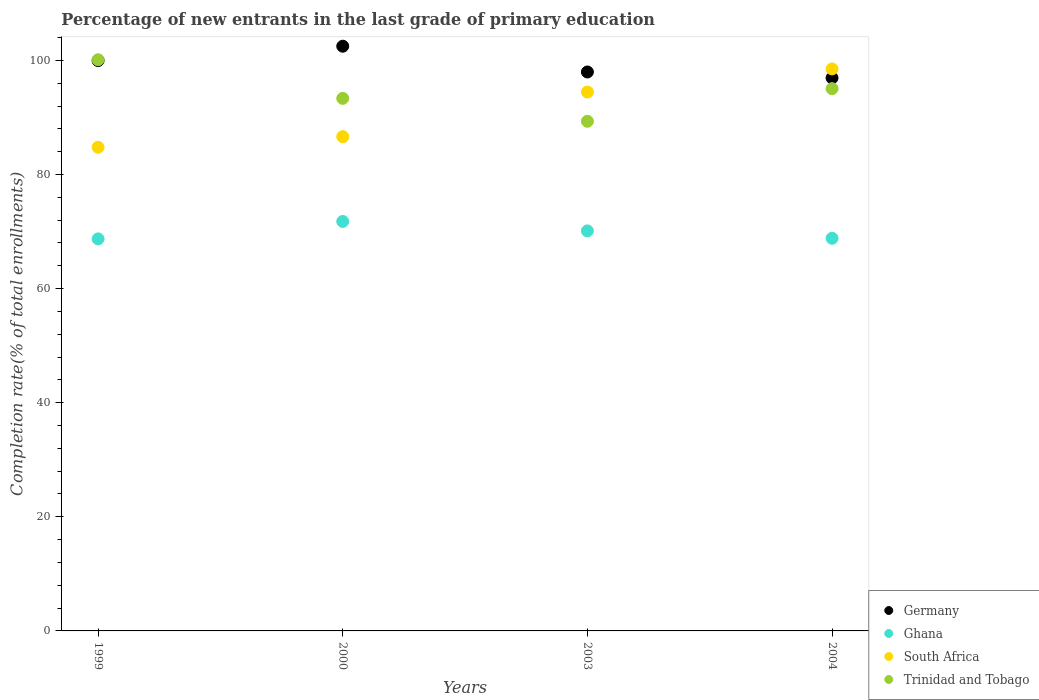How many different coloured dotlines are there?
Offer a very short reply. 4. What is the percentage of new entrants in Trinidad and Tobago in 2004?
Give a very brief answer. 95.05. Across all years, what is the maximum percentage of new entrants in Germany?
Provide a succinct answer. 102.49. Across all years, what is the minimum percentage of new entrants in Trinidad and Tobago?
Your answer should be very brief. 89.33. In which year was the percentage of new entrants in Trinidad and Tobago maximum?
Provide a succinct answer. 1999. What is the total percentage of new entrants in South Africa in the graph?
Your response must be concise. 364.36. What is the difference between the percentage of new entrants in Trinidad and Tobago in 2000 and that in 2004?
Keep it short and to the point. -1.7. What is the difference between the percentage of new entrants in Ghana in 1999 and the percentage of new entrants in South Africa in 2000?
Keep it short and to the point. -17.91. What is the average percentage of new entrants in Ghana per year?
Offer a terse response. 69.86. In the year 2000, what is the difference between the percentage of new entrants in Ghana and percentage of new entrants in Trinidad and Tobago?
Provide a succinct answer. -21.57. In how many years, is the percentage of new entrants in Trinidad and Tobago greater than 100 %?
Keep it short and to the point. 1. What is the ratio of the percentage of new entrants in Ghana in 1999 to that in 2000?
Provide a succinct answer. 0.96. Is the percentage of new entrants in South Africa in 2003 less than that in 2004?
Offer a very short reply. Yes. Is the difference between the percentage of new entrants in Ghana in 2000 and 2004 greater than the difference between the percentage of new entrants in Trinidad and Tobago in 2000 and 2004?
Make the answer very short. Yes. What is the difference between the highest and the second highest percentage of new entrants in Trinidad and Tobago?
Your answer should be compact. 5.07. What is the difference between the highest and the lowest percentage of new entrants in Trinidad and Tobago?
Keep it short and to the point. 10.78. Is the sum of the percentage of new entrants in Germany in 1999 and 2004 greater than the maximum percentage of new entrants in Trinidad and Tobago across all years?
Keep it short and to the point. Yes. Is it the case that in every year, the sum of the percentage of new entrants in Trinidad and Tobago and percentage of new entrants in Germany  is greater than the sum of percentage of new entrants in Ghana and percentage of new entrants in South Africa?
Your answer should be very brief. No. Does the percentage of new entrants in South Africa monotonically increase over the years?
Your response must be concise. Yes. Does the graph contain grids?
Keep it short and to the point. No. How many legend labels are there?
Keep it short and to the point. 4. What is the title of the graph?
Provide a short and direct response. Percentage of new entrants in the last grade of primary education. Does "Gambia, The" appear as one of the legend labels in the graph?
Offer a terse response. No. What is the label or title of the X-axis?
Provide a short and direct response. Years. What is the label or title of the Y-axis?
Your answer should be very brief. Completion rate(% of total enrollments). What is the Completion rate(% of total enrollments) in Germany in 1999?
Provide a succinct answer. 99.97. What is the Completion rate(% of total enrollments) of Ghana in 1999?
Offer a very short reply. 68.71. What is the Completion rate(% of total enrollments) of South Africa in 1999?
Offer a very short reply. 84.77. What is the Completion rate(% of total enrollments) of Trinidad and Tobago in 1999?
Provide a succinct answer. 100.11. What is the Completion rate(% of total enrollments) in Germany in 2000?
Ensure brevity in your answer.  102.49. What is the Completion rate(% of total enrollments) of Ghana in 2000?
Keep it short and to the point. 71.77. What is the Completion rate(% of total enrollments) in South Africa in 2000?
Make the answer very short. 86.62. What is the Completion rate(% of total enrollments) in Trinidad and Tobago in 2000?
Give a very brief answer. 93.35. What is the Completion rate(% of total enrollments) of Germany in 2003?
Offer a terse response. 97.97. What is the Completion rate(% of total enrollments) in Ghana in 2003?
Provide a succinct answer. 70.12. What is the Completion rate(% of total enrollments) in South Africa in 2003?
Your response must be concise. 94.45. What is the Completion rate(% of total enrollments) in Trinidad and Tobago in 2003?
Offer a terse response. 89.33. What is the Completion rate(% of total enrollments) of Germany in 2004?
Offer a terse response. 96.93. What is the Completion rate(% of total enrollments) of Ghana in 2004?
Offer a terse response. 68.82. What is the Completion rate(% of total enrollments) of South Africa in 2004?
Keep it short and to the point. 98.51. What is the Completion rate(% of total enrollments) of Trinidad and Tobago in 2004?
Offer a very short reply. 95.05. Across all years, what is the maximum Completion rate(% of total enrollments) of Germany?
Your answer should be very brief. 102.49. Across all years, what is the maximum Completion rate(% of total enrollments) of Ghana?
Give a very brief answer. 71.77. Across all years, what is the maximum Completion rate(% of total enrollments) in South Africa?
Keep it short and to the point. 98.51. Across all years, what is the maximum Completion rate(% of total enrollments) in Trinidad and Tobago?
Ensure brevity in your answer.  100.11. Across all years, what is the minimum Completion rate(% of total enrollments) in Germany?
Your answer should be very brief. 96.93. Across all years, what is the minimum Completion rate(% of total enrollments) in Ghana?
Your answer should be very brief. 68.71. Across all years, what is the minimum Completion rate(% of total enrollments) of South Africa?
Offer a very short reply. 84.77. Across all years, what is the minimum Completion rate(% of total enrollments) in Trinidad and Tobago?
Your answer should be very brief. 89.33. What is the total Completion rate(% of total enrollments) of Germany in the graph?
Offer a very short reply. 397.36. What is the total Completion rate(% of total enrollments) of Ghana in the graph?
Your response must be concise. 279.42. What is the total Completion rate(% of total enrollments) of South Africa in the graph?
Offer a very short reply. 364.36. What is the total Completion rate(% of total enrollments) of Trinidad and Tobago in the graph?
Offer a terse response. 377.84. What is the difference between the Completion rate(% of total enrollments) in Germany in 1999 and that in 2000?
Ensure brevity in your answer.  -2.52. What is the difference between the Completion rate(% of total enrollments) in Ghana in 1999 and that in 2000?
Your response must be concise. -3.06. What is the difference between the Completion rate(% of total enrollments) in South Africa in 1999 and that in 2000?
Provide a short and direct response. -1.85. What is the difference between the Completion rate(% of total enrollments) of Trinidad and Tobago in 1999 and that in 2000?
Your answer should be compact. 6.77. What is the difference between the Completion rate(% of total enrollments) in Germany in 1999 and that in 2003?
Provide a succinct answer. 1.99. What is the difference between the Completion rate(% of total enrollments) of Ghana in 1999 and that in 2003?
Offer a terse response. -1.4. What is the difference between the Completion rate(% of total enrollments) of South Africa in 1999 and that in 2003?
Ensure brevity in your answer.  -9.68. What is the difference between the Completion rate(% of total enrollments) of Trinidad and Tobago in 1999 and that in 2003?
Provide a succinct answer. 10.78. What is the difference between the Completion rate(% of total enrollments) in Germany in 1999 and that in 2004?
Give a very brief answer. 3.04. What is the difference between the Completion rate(% of total enrollments) in Ghana in 1999 and that in 2004?
Provide a short and direct response. -0.11. What is the difference between the Completion rate(% of total enrollments) in South Africa in 1999 and that in 2004?
Give a very brief answer. -13.73. What is the difference between the Completion rate(% of total enrollments) in Trinidad and Tobago in 1999 and that in 2004?
Ensure brevity in your answer.  5.07. What is the difference between the Completion rate(% of total enrollments) in Germany in 2000 and that in 2003?
Ensure brevity in your answer.  4.52. What is the difference between the Completion rate(% of total enrollments) of Ghana in 2000 and that in 2003?
Your answer should be compact. 1.66. What is the difference between the Completion rate(% of total enrollments) of South Africa in 2000 and that in 2003?
Offer a very short reply. -7.83. What is the difference between the Completion rate(% of total enrollments) in Trinidad and Tobago in 2000 and that in 2003?
Provide a short and direct response. 4.02. What is the difference between the Completion rate(% of total enrollments) in Germany in 2000 and that in 2004?
Ensure brevity in your answer.  5.56. What is the difference between the Completion rate(% of total enrollments) of Ghana in 2000 and that in 2004?
Your answer should be compact. 2.95. What is the difference between the Completion rate(% of total enrollments) in South Africa in 2000 and that in 2004?
Provide a short and direct response. -11.88. What is the difference between the Completion rate(% of total enrollments) of Trinidad and Tobago in 2000 and that in 2004?
Ensure brevity in your answer.  -1.7. What is the difference between the Completion rate(% of total enrollments) of Germany in 2003 and that in 2004?
Provide a succinct answer. 1.04. What is the difference between the Completion rate(% of total enrollments) in Ghana in 2003 and that in 2004?
Offer a terse response. 1.3. What is the difference between the Completion rate(% of total enrollments) of South Africa in 2003 and that in 2004?
Provide a succinct answer. -4.06. What is the difference between the Completion rate(% of total enrollments) of Trinidad and Tobago in 2003 and that in 2004?
Offer a terse response. -5.71. What is the difference between the Completion rate(% of total enrollments) in Germany in 1999 and the Completion rate(% of total enrollments) in Ghana in 2000?
Ensure brevity in your answer.  28.19. What is the difference between the Completion rate(% of total enrollments) in Germany in 1999 and the Completion rate(% of total enrollments) in South Africa in 2000?
Offer a very short reply. 13.34. What is the difference between the Completion rate(% of total enrollments) in Germany in 1999 and the Completion rate(% of total enrollments) in Trinidad and Tobago in 2000?
Give a very brief answer. 6.62. What is the difference between the Completion rate(% of total enrollments) of Ghana in 1999 and the Completion rate(% of total enrollments) of South Africa in 2000?
Keep it short and to the point. -17.91. What is the difference between the Completion rate(% of total enrollments) of Ghana in 1999 and the Completion rate(% of total enrollments) of Trinidad and Tobago in 2000?
Your response must be concise. -24.63. What is the difference between the Completion rate(% of total enrollments) of South Africa in 1999 and the Completion rate(% of total enrollments) of Trinidad and Tobago in 2000?
Provide a succinct answer. -8.57. What is the difference between the Completion rate(% of total enrollments) in Germany in 1999 and the Completion rate(% of total enrollments) in Ghana in 2003?
Offer a very short reply. 29.85. What is the difference between the Completion rate(% of total enrollments) of Germany in 1999 and the Completion rate(% of total enrollments) of South Africa in 2003?
Give a very brief answer. 5.52. What is the difference between the Completion rate(% of total enrollments) in Germany in 1999 and the Completion rate(% of total enrollments) in Trinidad and Tobago in 2003?
Ensure brevity in your answer.  10.63. What is the difference between the Completion rate(% of total enrollments) of Ghana in 1999 and the Completion rate(% of total enrollments) of South Africa in 2003?
Your answer should be very brief. -25.74. What is the difference between the Completion rate(% of total enrollments) in Ghana in 1999 and the Completion rate(% of total enrollments) in Trinidad and Tobago in 2003?
Give a very brief answer. -20.62. What is the difference between the Completion rate(% of total enrollments) in South Africa in 1999 and the Completion rate(% of total enrollments) in Trinidad and Tobago in 2003?
Ensure brevity in your answer.  -4.56. What is the difference between the Completion rate(% of total enrollments) in Germany in 1999 and the Completion rate(% of total enrollments) in Ghana in 2004?
Offer a terse response. 31.15. What is the difference between the Completion rate(% of total enrollments) of Germany in 1999 and the Completion rate(% of total enrollments) of South Africa in 2004?
Make the answer very short. 1.46. What is the difference between the Completion rate(% of total enrollments) of Germany in 1999 and the Completion rate(% of total enrollments) of Trinidad and Tobago in 2004?
Give a very brief answer. 4.92. What is the difference between the Completion rate(% of total enrollments) in Ghana in 1999 and the Completion rate(% of total enrollments) in South Africa in 2004?
Provide a succinct answer. -29.79. What is the difference between the Completion rate(% of total enrollments) of Ghana in 1999 and the Completion rate(% of total enrollments) of Trinidad and Tobago in 2004?
Make the answer very short. -26.33. What is the difference between the Completion rate(% of total enrollments) of South Africa in 1999 and the Completion rate(% of total enrollments) of Trinidad and Tobago in 2004?
Your answer should be very brief. -10.27. What is the difference between the Completion rate(% of total enrollments) of Germany in 2000 and the Completion rate(% of total enrollments) of Ghana in 2003?
Your answer should be compact. 32.37. What is the difference between the Completion rate(% of total enrollments) of Germany in 2000 and the Completion rate(% of total enrollments) of South Africa in 2003?
Keep it short and to the point. 8.04. What is the difference between the Completion rate(% of total enrollments) of Germany in 2000 and the Completion rate(% of total enrollments) of Trinidad and Tobago in 2003?
Give a very brief answer. 13.16. What is the difference between the Completion rate(% of total enrollments) of Ghana in 2000 and the Completion rate(% of total enrollments) of South Africa in 2003?
Keep it short and to the point. -22.68. What is the difference between the Completion rate(% of total enrollments) in Ghana in 2000 and the Completion rate(% of total enrollments) in Trinidad and Tobago in 2003?
Your response must be concise. -17.56. What is the difference between the Completion rate(% of total enrollments) in South Africa in 2000 and the Completion rate(% of total enrollments) in Trinidad and Tobago in 2003?
Your answer should be very brief. -2.71. What is the difference between the Completion rate(% of total enrollments) in Germany in 2000 and the Completion rate(% of total enrollments) in Ghana in 2004?
Your answer should be compact. 33.67. What is the difference between the Completion rate(% of total enrollments) of Germany in 2000 and the Completion rate(% of total enrollments) of South Africa in 2004?
Provide a succinct answer. 3.98. What is the difference between the Completion rate(% of total enrollments) in Germany in 2000 and the Completion rate(% of total enrollments) in Trinidad and Tobago in 2004?
Keep it short and to the point. 7.44. What is the difference between the Completion rate(% of total enrollments) in Ghana in 2000 and the Completion rate(% of total enrollments) in South Africa in 2004?
Your answer should be compact. -26.73. What is the difference between the Completion rate(% of total enrollments) of Ghana in 2000 and the Completion rate(% of total enrollments) of Trinidad and Tobago in 2004?
Provide a short and direct response. -23.27. What is the difference between the Completion rate(% of total enrollments) of South Africa in 2000 and the Completion rate(% of total enrollments) of Trinidad and Tobago in 2004?
Offer a terse response. -8.42. What is the difference between the Completion rate(% of total enrollments) of Germany in 2003 and the Completion rate(% of total enrollments) of Ghana in 2004?
Make the answer very short. 29.15. What is the difference between the Completion rate(% of total enrollments) of Germany in 2003 and the Completion rate(% of total enrollments) of South Africa in 2004?
Your answer should be compact. -0.54. What is the difference between the Completion rate(% of total enrollments) in Germany in 2003 and the Completion rate(% of total enrollments) in Trinidad and Tobago in 2004?
Provide a short and direct response. 2.93. What is the difference between the Completion rate(% of total enrollments) of Ghana in 2003 and the Completion rate(% of total enrollments) of South Africa in 2004?
Your answer should be very brief. -28.39. What is the difference between the Completion rate(% of total enrollments) in Ghana in 2003 and the Completion rate(% of total enrollments) in Trinidad and Tobago in 2004?
Your answer should be compact. -24.93. What is the difference between the Completion rate(% of total enrollments) of South Africa in 2003 and the Completion rate(% of total enrollments) of Trinidad and Tobago in 2004?
Offer a very short reply. -0.6. What is the average Completion rate(% of total enrollments) of Germany per year?
Provide a short and direct response. 99.34. What is the average Completion rate(% of total enrollments) of Ghana per year?
Your response must be concise. 69.86. What is the average Completion rate(% of total enrollments) in South Africa per year?
Your response must be concise. 91.09. What is the average Completion rate(% of total enrollments) in Trinidad and Tobago per year?
Ensure brevity in your answer.  94.46. In the year 1999, what is the difference between the Completion rate(% of total enrollments) of Germany and Completion rate(% of total enrollments) of Ghana?
Your answer should be compact. 31.25. In the year 1999, what is the difference between the Completion rate(% of total enrollments) in Germany and Completion rate(% of total enrollments) in South Africa?
Your answer should be compact. 15.19. In the year 1999, what is the difference between the Completion rate(% of total enrollments) in Germany and Completion rate(% of total enrollments) in Trinidad and Tobago?
Keep it short and to the point. -0.15. In the year 1999, what is the difference between the Completion rate(% of total enrollments) of Ghana and Completion rate(% of total enrollments) of South Africa?
Keep it short and to the point. -16.06. In the year 1999, what is the difference between the Completion rate(% of total enrollments) in Ghana and Completion rate(% of total enrollments) in Trinidad and Tobago?
Your answer should be compact. -31.4. In the year 1999, what is the difference between the Completion rate(% of total enrollments) in South Africa and Completion rate(% of total enrollments) in Trinidad and Tobago?
Your answer should be compact. -15.34. In the year 2000, what is the difference between the Completion rate(% of total enrollments) in Germany and Completion rate(% of total enrollments) in Ghana?
Give a very brief answer. 30.71. In the year 2000, what is the difference between the Completion rate(% of total enrollments) of Germany and Completion rate(% of total enrollments) of South Africa?
Ensure brevity in your answer.  15.86. In the year 2000, what is the difference between the Completion rate(% of total enrollments) of Germany and Completion rate(% of total enrollments) of Trinidad and Tobago?
Provide a short and direct response. 9.14. In the year 2000, what is the difference between the Completion rate(% of total enrollments) of Ghana and Completion rate(% of total enrollments) of South Africa?
Offer a very short reply. -14.85. In the year 2000, what is the difference between the Completion rate(% of total enrollments) in Ghana and Completion rate(% of total enrollments) in Trinidad and Tobago?
Offer a terse response. -21.57. In the year 2000, what is the difference between the Completion rate(% of total enrollments) in South Africa and Completion rate(% of total enrollments) in Trinidad and Tobago?
Your response must be concise. -6.72. In the year 2003, what is the difference between the Completion rate(% of total enrollments) in Germany and Completion rate(% of total enrollments) in Ghana?
Provide a short and direct response. 27.85. In the year 2003, what is the difference between the Completion rate(% of total enrollments) of Germany and Completion rate(% of total enrollments) of South Africa?
Provide a succinct answer. 3.52. In the year 2003, what is the difference between the Completion rate(% of total enrollments) in Germany and Completion rate(% of total enrollments) in Trinidad and Tobago?
Your answer should be very brief. 8.64. In the year 2003, what is the difference between the Completion rate(% of total enrollments) of Ghana and Completion rate(% of total enrollments) of South Africa?
Make the answer very short. -24.33. In the year 2003, what is the difference between the Completion rate(% of total enrollments) in Ghana and Completion rate(% of total enrollments) in Trinidad and Tobago?
Provide a succinct answer. -19.21. In the year 2003, what is the difference between the Completion rate(% of total enrollments) of South Africa and Completion rate(% of total enrollments) of Trinidad and Tobago?
Ensure brevity in your answer.  5.12. In the year 2004, what is the difference between the Completion rate(% of total enrollments) of Germany and Completion rate(% of total enrollments) of Ghana?
Offer a terse response. 28.11. In the year 2004, what is the difference between the Completion rate(% of total enrollments) in Germany and Completion rate(% of total enrollments) in South Africa?
Offer a terse response. -1.58. In the year 2004, what is the difference between the Completion rate(% of total enrollments) in Germany and Completion rate(% of total enrollments) in Trinidad and Tobago?
Your response must be concise. 1.88. In the year 2004, what is the difference between the Completion rate(% of total enrollments) in Ghana and Completion rate(% of total enrollments) in South Africa?
Make the answer very short. -29.69. In the year 2004, what is the difference between the Completion rate(% of total enrollments) of Ghana and Completion rate(% of total enrollments) of Trinidad and Tobago?
Your answer should be very brief. -26.23. In the year 2004, what is the difference between the Completion rate(% of total enrollments) in South Africa and Completion rate(% of total enrollments) in Trinidad and Tobago?
Ensure brevity in your answer.  3.46. What is the ratio of the Completion rate(% of total enrollments) in Germany in 1999 to that in 2000?
Make the answer very short. 0.98. What is the ratio of the Completion rate(% of total enrollments) of Ghana in 1999 to that in 2000?
Provide a succinct answer. 0.96. What is the ratio of the Completion rate(% of total enrollments) of South Africa in 1999 to that in 2000?
Your answer should be compact. 0.98. What is the ratio of the Completion rate(% of total enrollments) of Trinidad and Tobago in 1999 to that in 2000?
Keep it short and to the point. 1.07. What is the ratio of the Completion rate(% of total enrollments) of Germany in 1999 to that in 2003?
Your response must be concise. 1.02. What is the ratio of the Completion rate(% of total enrollments) of Ghana in 1999 to that in 2003?
Provide a succinct answer. 0.98. What is the ratio of the Completion rate(% of total enrollments) in South Africa in 1999 to that in 2003?
Provide a short and direct response. 0.9. What is the ratio of the Completion rate(% of total enrollments) in Trinidad and Tobago in 1999 to that in 2003?
Provide a succinct answer. 1.12. What is the ratio of the Completion rate(% of total enrollments) in Germany in 1999 to that in 2004?
Ensure brevity in your answer.  1.03. What is the ratio of the Completion rate(% of total enrollments) of South Africa in 1999 to that in 2004?
Your response must be concise. 0.86. What is the ratio of the Completion rate(% of total enrollments) in Trinidad and Tobago in 1999 to that in 2004?
Keep it short and to the point. 1.05. What is the ratio of the Completion rate(% of total enrollments) of Germany in 2000 to that in 2003?
Your answer should be very brief. 1.05. What is the ratio of the Completion rate(% of total enrollments) of Ghana in 2000 to that in 2003?
Your answer should be very brief. 1.02. What is the ratio of the Completion rate(% of total enrollments) of South Africa in 2000 to that in 2003?
Offer a very short reply. 0.92. What is the ratio of the Completion rate(% of total enrollments) of Trinidad and Tobago in 2000 to that in 2003?
Offer a terse response. 1.04. What is the ratio of the Completion rate(% of total enrollments) of Germany in 2000 to that in 2004?
Give a very brief answer. 1.06. What is the ratio of the Completion rate(% of total enrollments) of Ghana in 2000 to that in 2004?
Make the answer very short. 1.04. What is the ratio of the Completion rate(% of total enrollments) of South Africa in 2000 to that in 2004?
Your answer should be compact. 0.88. What is the ratio of the Completion rate(% of total enrollments) in Trinidad and Tobago in 2000 to that in 2004?
Ensure brevity in your answer.  0.98. What is the ratio of the Completion rate(% of total enrollments) in Germany in 2003 to that in 2004?
Ensure brevity in your answer.  1.01. What is the ratio of the Completion rate(% of total enrollments) of Ghana in 2003 to that in 2004?
Your answer should be compact. 1.02. What is the ratio of the Completion rate(% of total enrollments) in South Africa in 2003 to that in 2004?
Your answer should be very brief. 0.96. What is the ratio of the Completion rate(% of total enrollments) of Trinidad and Tobago in 2003 to that in 2004?
Offer a terse response. 0.94. What is the difference between the highest and the second highest Completion rate(% of total enrollments) in Germany?
Ensure brevity in your answer.  2.52. What is the difference between the highest and the second highest Completion rate(% of total enrollments) in Ghana?
Your response must be concise. 1.66. What is the difference between the highest and the second highest Completion rate(% of total enrollments) in South Africa?
Make the answer very short. 4.06. What is the difference between the highest and the second highest Completion rate(% of total enrollments) of Trinidad and Tobago?
Offer a terse response. 5.07. What is the difference between the highest and the lowest Completion rate(% of total enrollments) in Germany?
Your answer should be compact. 5.56. What is the difference between the highest and the lowest Completion rate(% of total enrollments) in Ghana?
Your answer should be very brief. 3.06. What is the difference between the highest and the lowest Completion rate(% of total enrollments) of South Africa?
Your answer should be very brief. 13.73. What is the difference between the highest and the lowest Completion rate(% of total enrollments) of Trinidad and Tobago?
Your answer should be very brief. 10.78. 